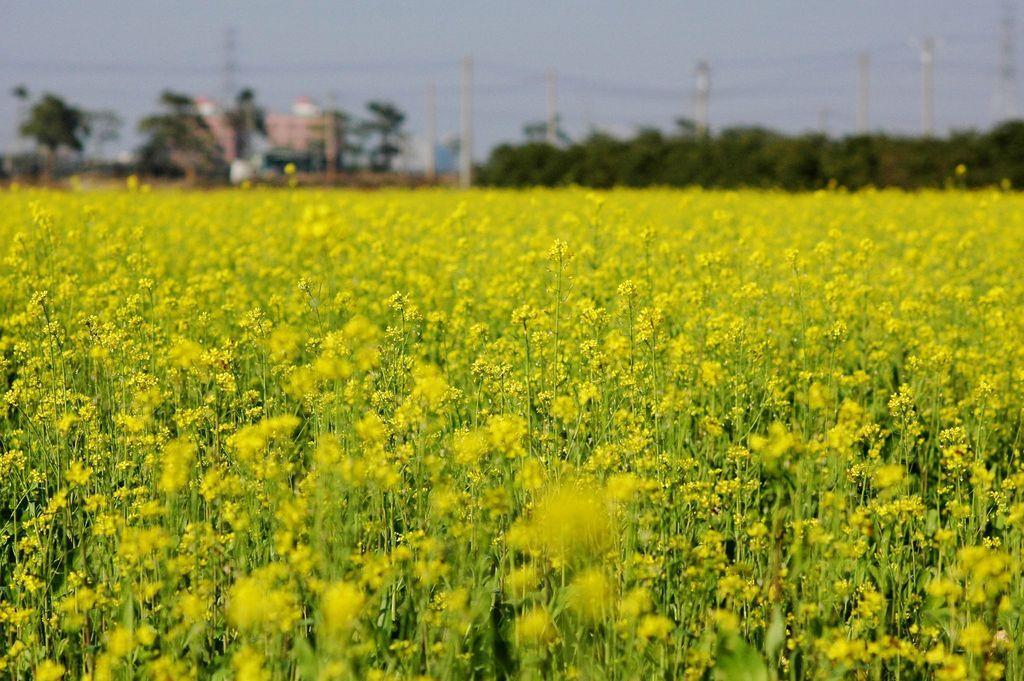Can you describe this image briefly? In this image at the bottom there are many plants, flowers. In the middle there are trees, buildings, electric poles, cables and sky. 